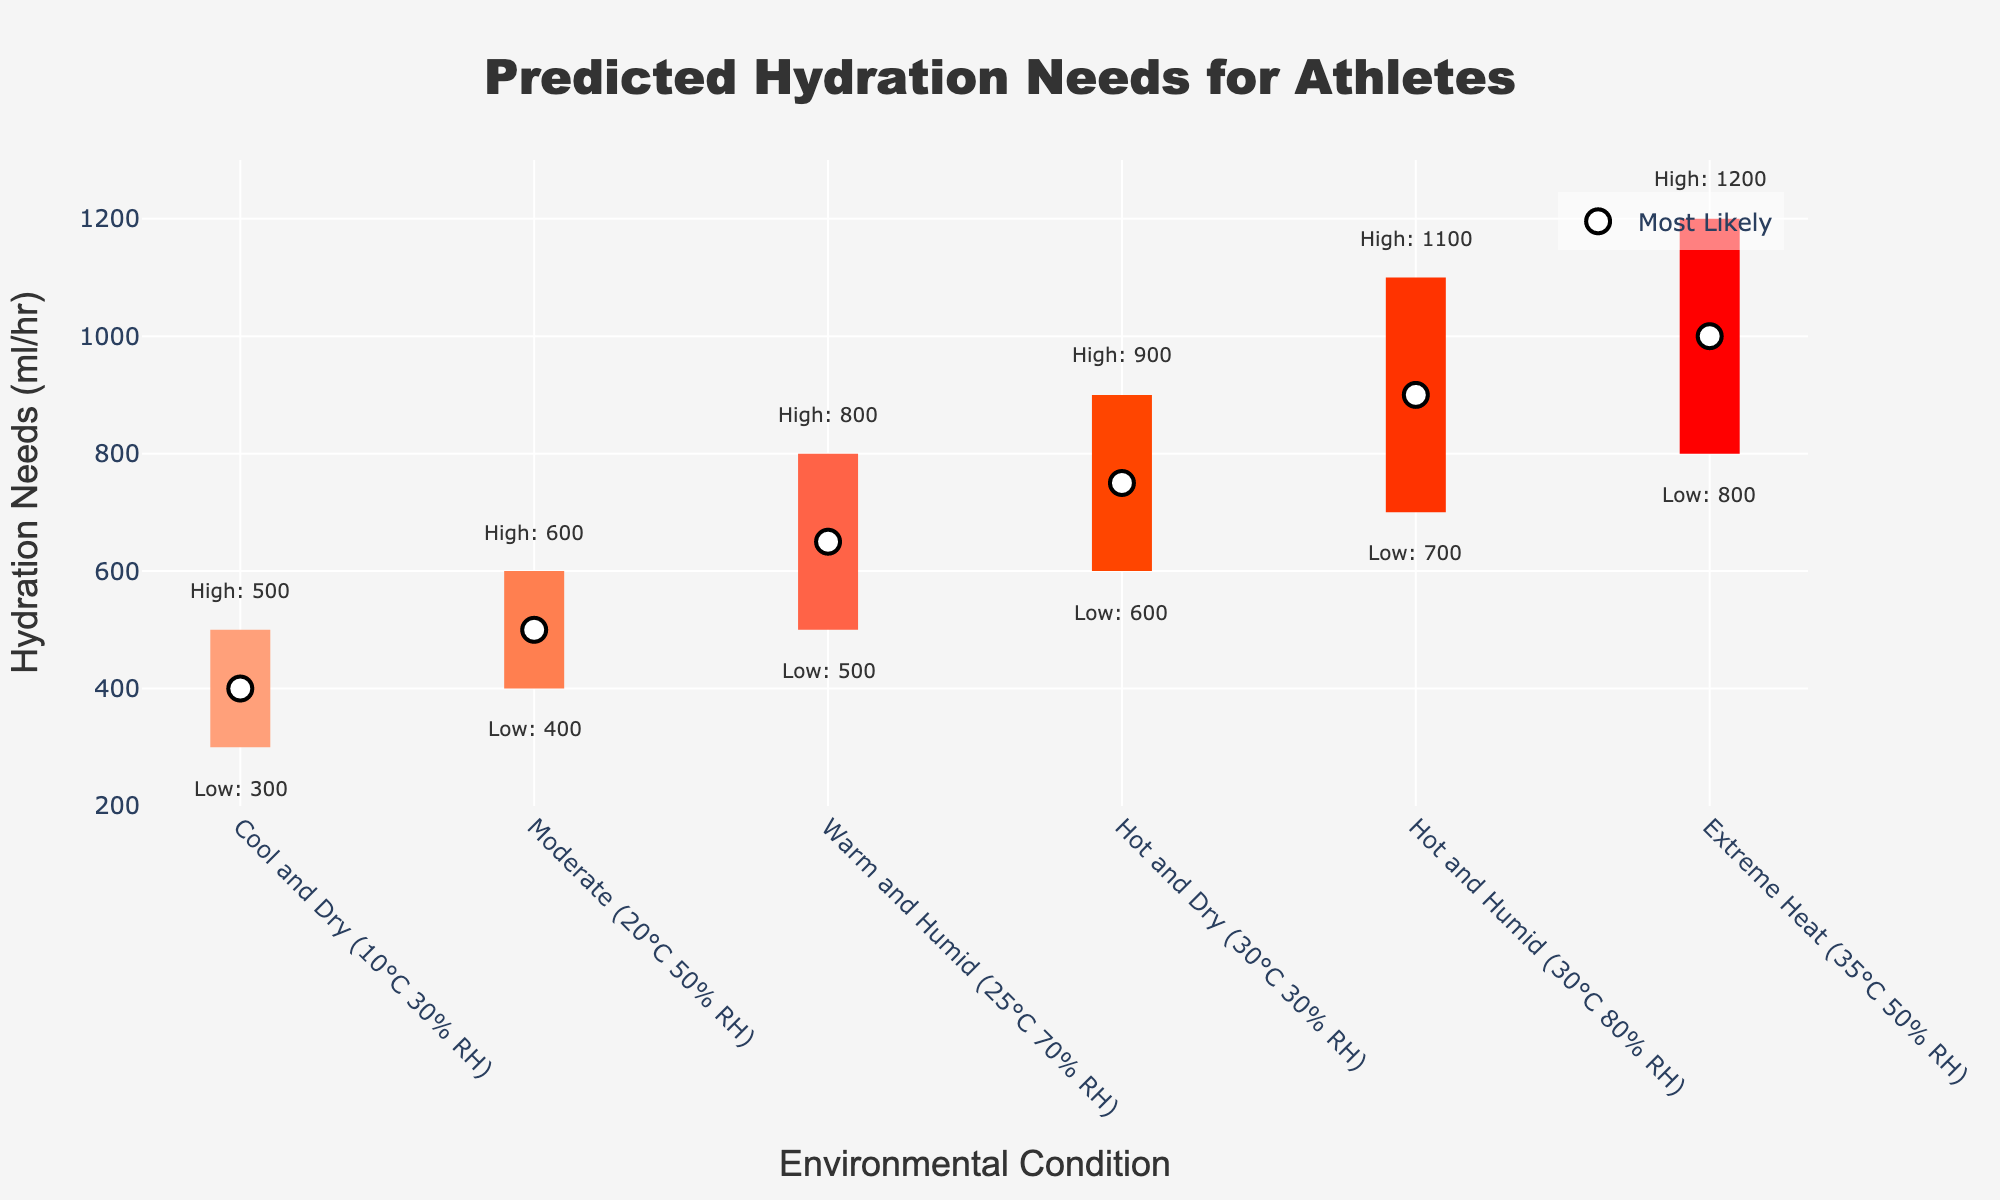How many environmental conditions are shown in the plot? The plot displays hydration needs predictions for different environmental conditions. Simply count the number of distinct conditions on the x-axis.
Answer: 6 What's the highest hydration need estimate for "Hot and Humid" conditions? To find the highest hydration need estimate for "Hot and Humid," locate the corresponding value on the plot for this condition.
Answer: 1100 ml/hr Which condition has the lowest "most likely" hydration need estimate? Identify the "most likely" values for all conditions from the markers, then find the smallest value and its corresponding condition.
Answer: Cool and Dry (10°C 30% RH) What is the range of hydration needs for "Moderate" conditions? Find the "Moderate" condition on the x-axis, then determine the difference between the high and low estimates in this condition. The low estimate is 400 ml/hr, and the high estimate is 600 ml/hr, so the range is 600-400.
Answer: 200 ml/hr How does the hydration need for "Extreme Heat" compare to "Cool and Dry"? Compare the most likely hydration need estimates, high estimates, and low estimates for both conditions directly from the plot. "Extreme Heat" has 1000 ml/hr ("most likely"), 1200 ml/hr (high), and 800 ml/hr (low), whereas "Cool and Dry" has 400 ml/hr, 500 ml/hr, and 300 ml/hr respectively.
Answer: Higher in "Extreme Heat" What's the average "most likely" hydration need across all conditions? Sum all "most likely" values: 400, 500, 650, 750, 900, 1000, then divide by the number of conditions (6). ((400 + 500 + 650 + 750 + 900 + 1000) / 6) = 700 ml/hr
Answer: 700 ml/hr Which condition shows the greatest variability in hydration needs? Assess the variability by subtracting the low estimate from the high estimate for each condition. Find the largest difference among the conditions. "Hot and Humid" (1100-700=400 ml/hr) shows the greatest variability.
Answer: Hot and Humid What color represents the hydration needs for "Warm and Humid" conditions? Identify the color band corresponding to the "Warm and Humid" condition from the plot, it's the third band from the left.
Answer: Orange If an athlete were to transition from "Cool and Dry" to "Hot and Dry" conditions, how much would their most likely hydration need increase? Subtract the "most likely" hydration need for "Cool and Dry" (400 ml/hr) from that for "Hot and Dry" (750 ml/hr). 750 - 400 = 350 ml/hr
Answer: 350 ml/hr How does the "Low Estimate" value for "Warm and Humid" compare to the "Most Likely" value for "Cool and Dry"? Compare the "Low Estimate" of "Warm and Humid" with "Most Likely" value of "Cool and Dry" directly from the plot. Both values are 500 ml/hr, making them equal.
Answer: Equal 